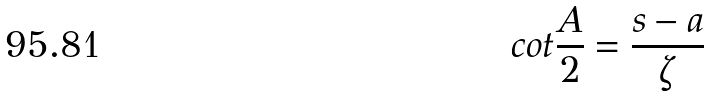Convert formula to latex. <formula><loc_0><loc_0><loc_500><loc_500>c o t \frac { A } { 2 } = \frac { s - a } { \zeta }</formula> 